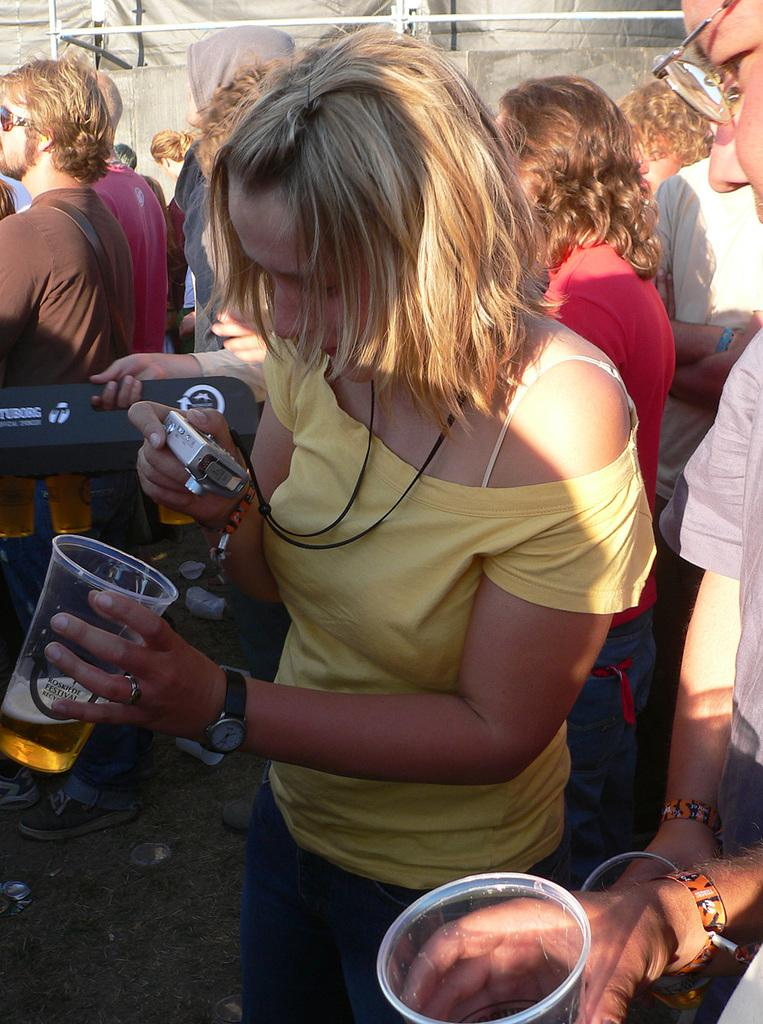How many people are in the image? There are persons standing in the image. Can you describe the woman's clothing? The woman is wearing a yellow shirt. What is the woman holding in the image? The woman is holding a camera. What is the woman doing with the glass in the image? The woman is taking a snapshot of the glass through the camera. What type of prose is the woman reading in the image? There is no indication in the image that the woman is reading any prose, as she is holding a camera and taking a snapshot of the glass. 